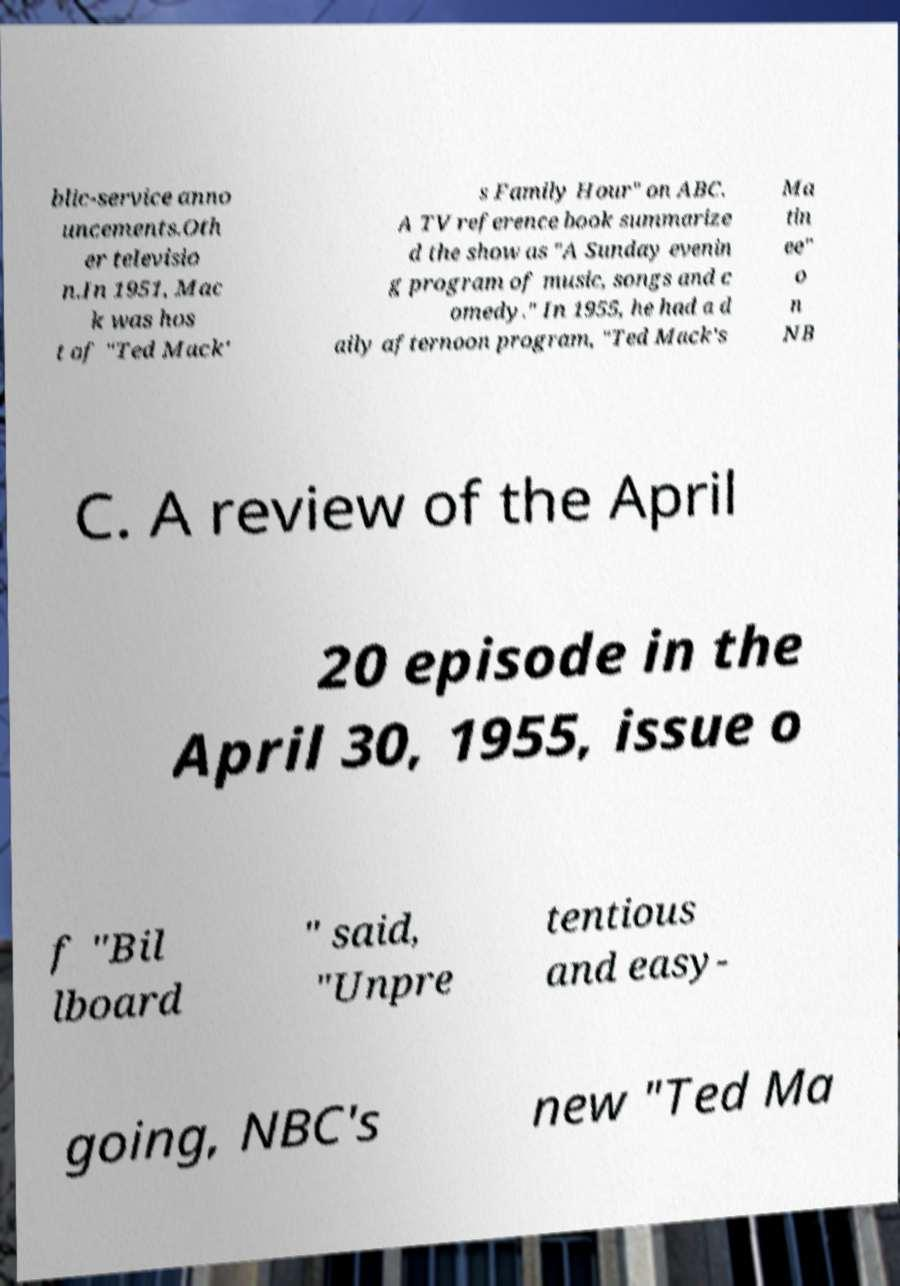For documentation purposes, I need the text within this image transcribed. Could you provide that? blic-service anno uncements.Oth er televisio n.In 1951, Mac k was hos t of "Ted Mack' s Family Hour" on ABC. A TV reference book summarize d the show as "A Sunday evenin g program of music, songs and c omedy." In 1955, he had a d aily afternoon program, "Ted Mack's Ma tin ee" o n NB C. A review of the April 20 episode in the April 30, 1955, issue o f "Bil lboard " said, "Unpre tentious and easy- going, NBC's new "Ted Ma 